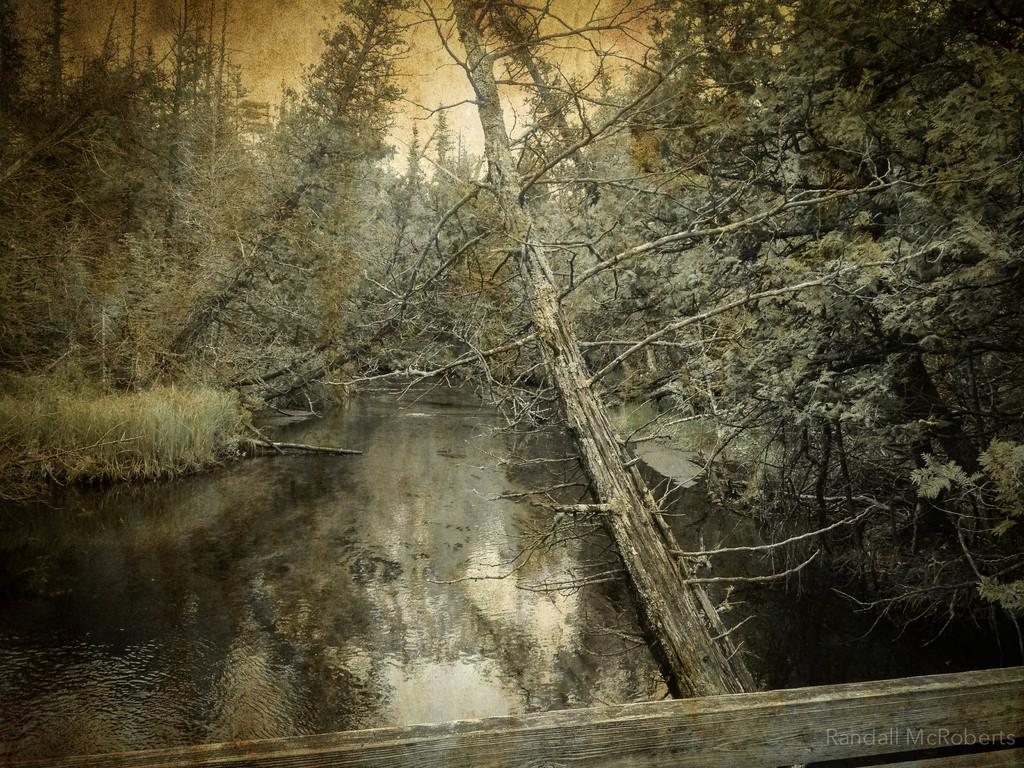What type of natural elements can be seen in the image? There are trees and water visible in the image. What type of structure is present in the image? There appears to be a wooden bridge at the bottom of the image. Where is the text located in the image? The text is at the bottom right corner of the image. What is visible in the background of the image? The sky is visible in the image. What type of jewel can be seen hanging from the trees in the image? There are no jewels present in the image; it features trees, water, a wooden bridge, and text. How does the family interact with the wooden bridge in the image? There is no family present in the image, and therefore no interaction with the wooden bridge can be observed. 